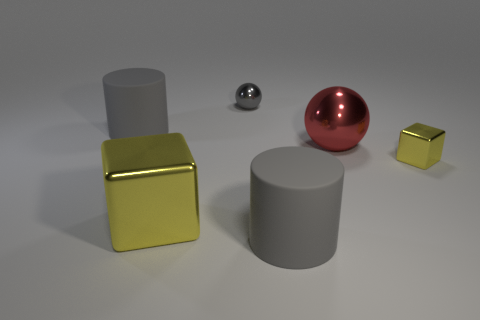The small sphere is what color?
Your response must be concise. Gray. How many metallic things are either big cylinders or tiny yellow cubes?
Offer a very short reply. 1. The large object that is the same shape as the tiny yellow metallic object is what color?
Keep it short and to the point. Yellow. Is there a tiny yellow metallic object?
Your response must be concise. Yes. Is the material of the yellow thing that is on the right side of the big shiny sphere the same as the large gray cylinder that is right of the tiny gray sphere?
Ensure brevity in your answer.  No. The metal object that is the same color as the big shiny block is what shape?
Make the answer very short. Cube. What number of objects are either big cylinders that are behind the large cube or large gray rubber things behind the large block?
Your answer should be very brief. 1. Does the large thing behind the red shiny object have the same color as the metal thing that is in front of the tiny yellow thing?
Provide a succinct answer. No. The thing that is behind the big yellow metallic block and left of the small ball has what shape?
Your answer should be very brief. Cylinder. What is the color of the metal thing that is the same size as the red shiny ball?
Give a very brief answer. Yellow. 